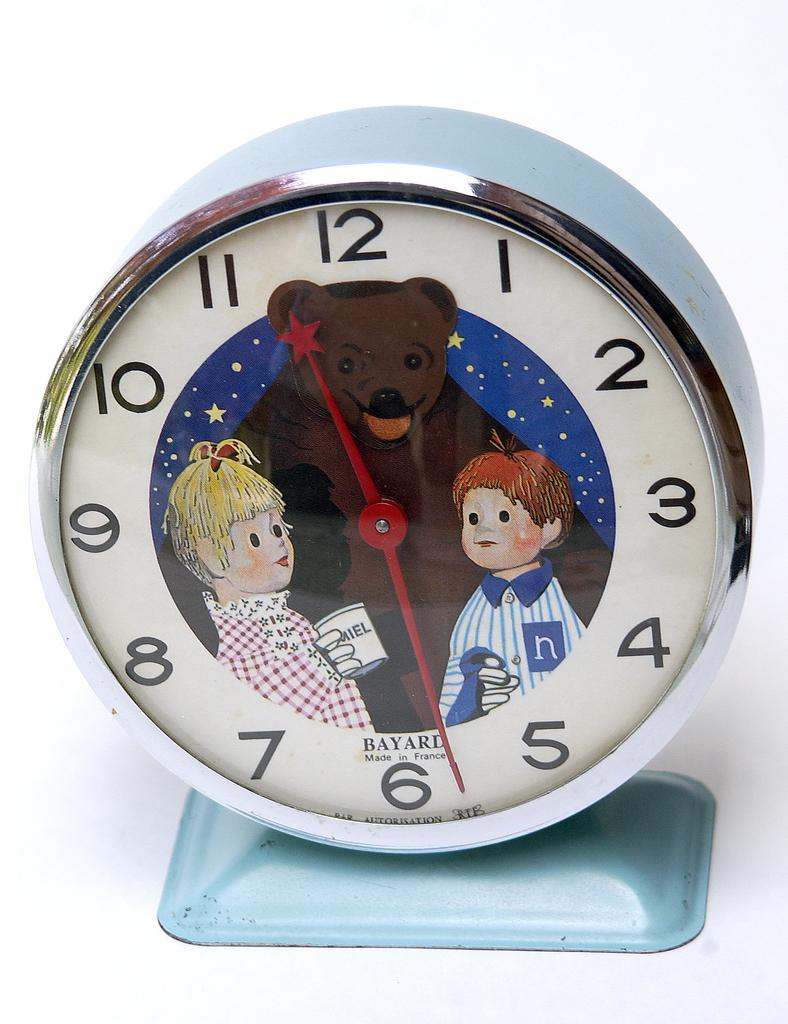Where was this clock made?
Keep it short and to the point. France. 